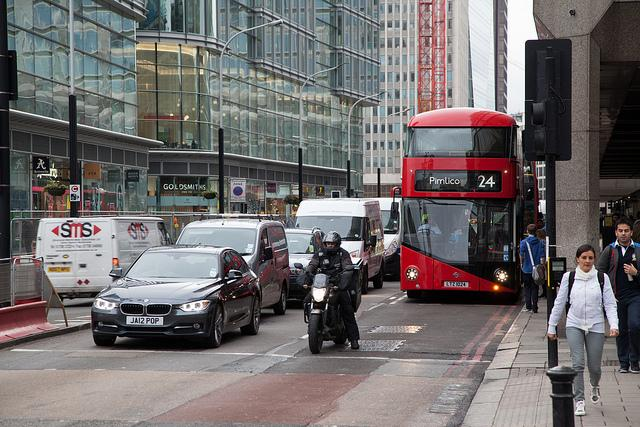What area of London does the bus go to? Please explain your reasoning. central. The area is central. 